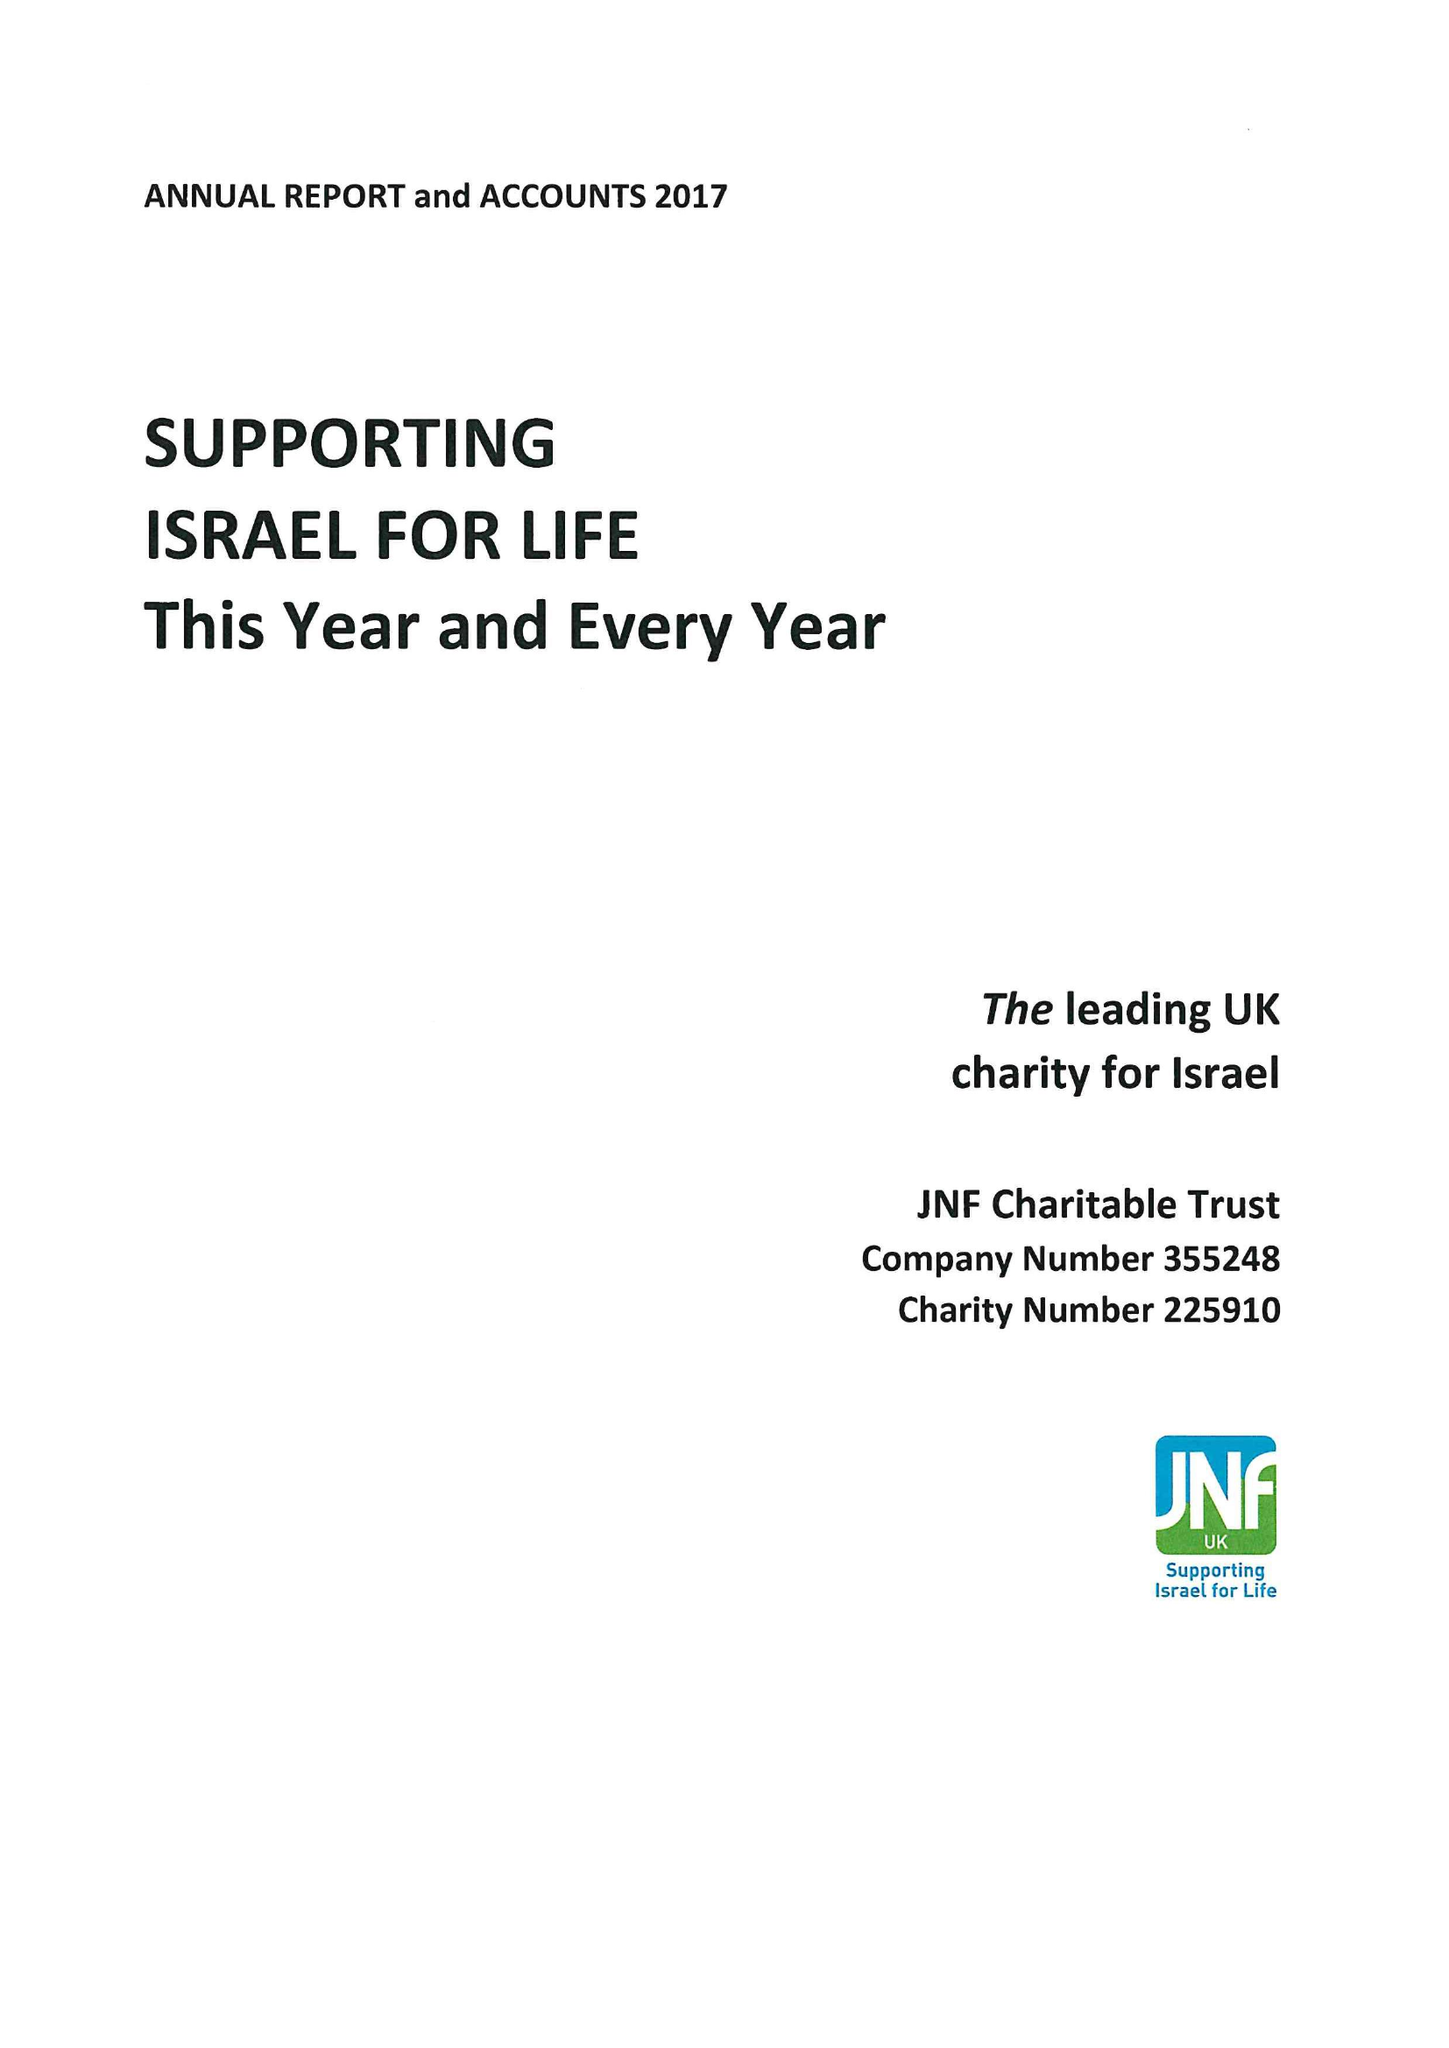What is the value for the income_annually_in_british_pounds?
Answer the question using a single word or phrase. 17038000.00 